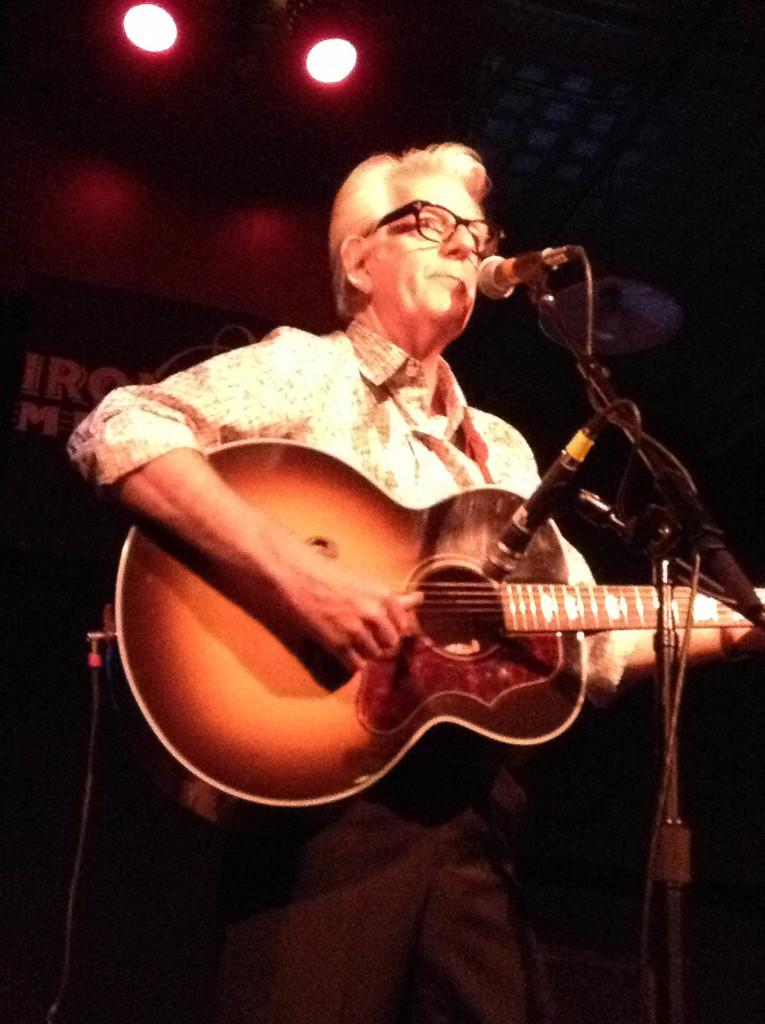What is the man in the image doing? The man is playing a guitar and singing in front of a microphone. What is the man wearing while performing? The man is wearing spectacles. What can be seen in the background of the image? There is a wall and lights visible in the background. What type of jail can be seen in the image? There is no jail present in the image. What is the texture of the guitar strings in the image? The image does not provide enough detail to determine the texture of the guitar strings. 